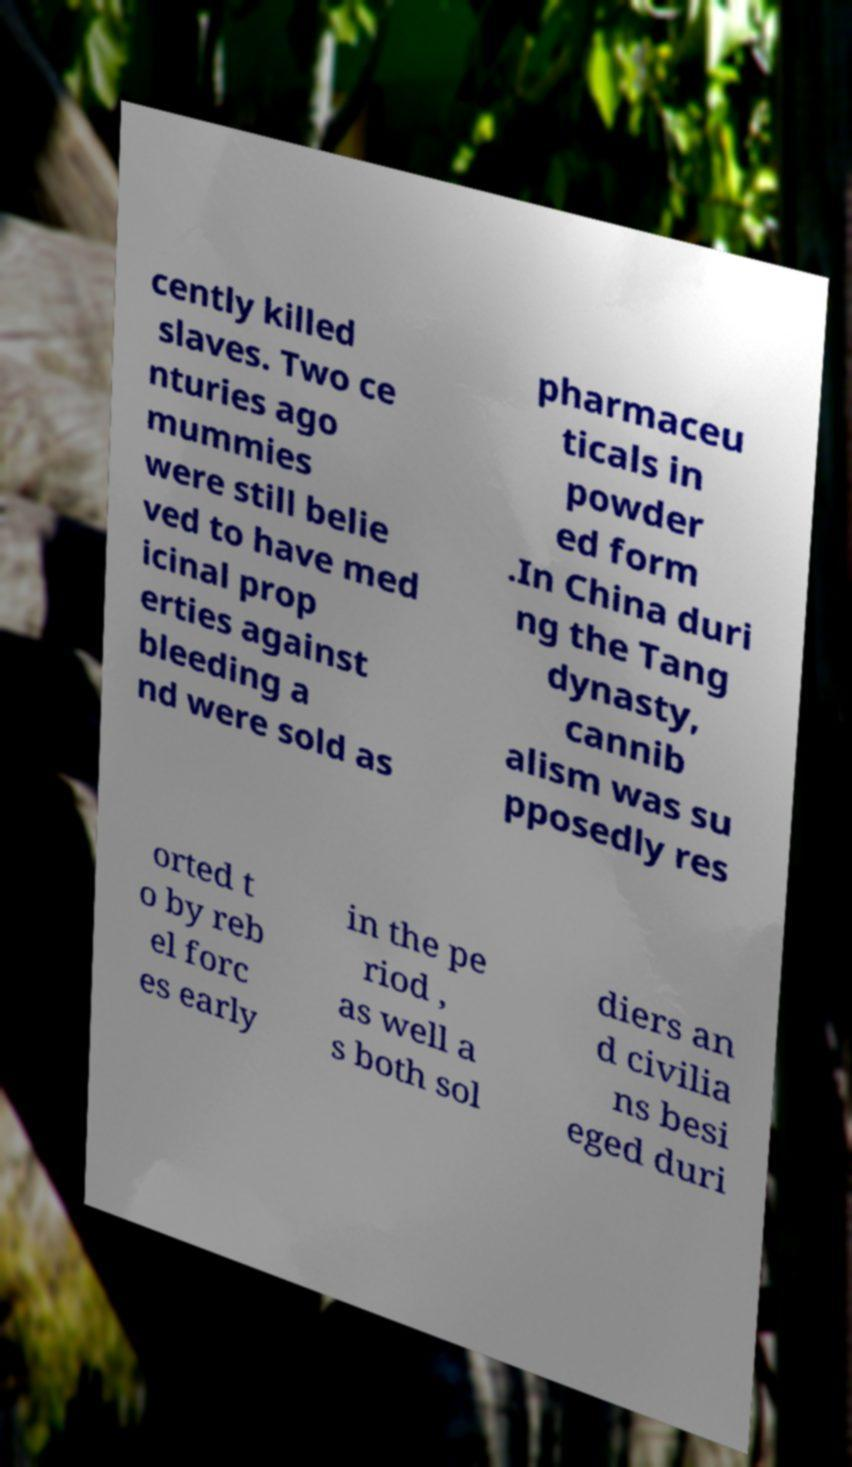I need the written content from this picture converted into text. Can you do that? cently killed slaves. Two ce nturies ago mummies were still belie ved to have med icinal prop erties against bleeding a nd were sold as pharmaceu ticals in powder ed form .In China duri ng the Tang dynasty, cannib alism was su pposedly res orted t o by reb el forc es early in the pe riod , as well a s both sol diers an d civilia ns besi eged duri 